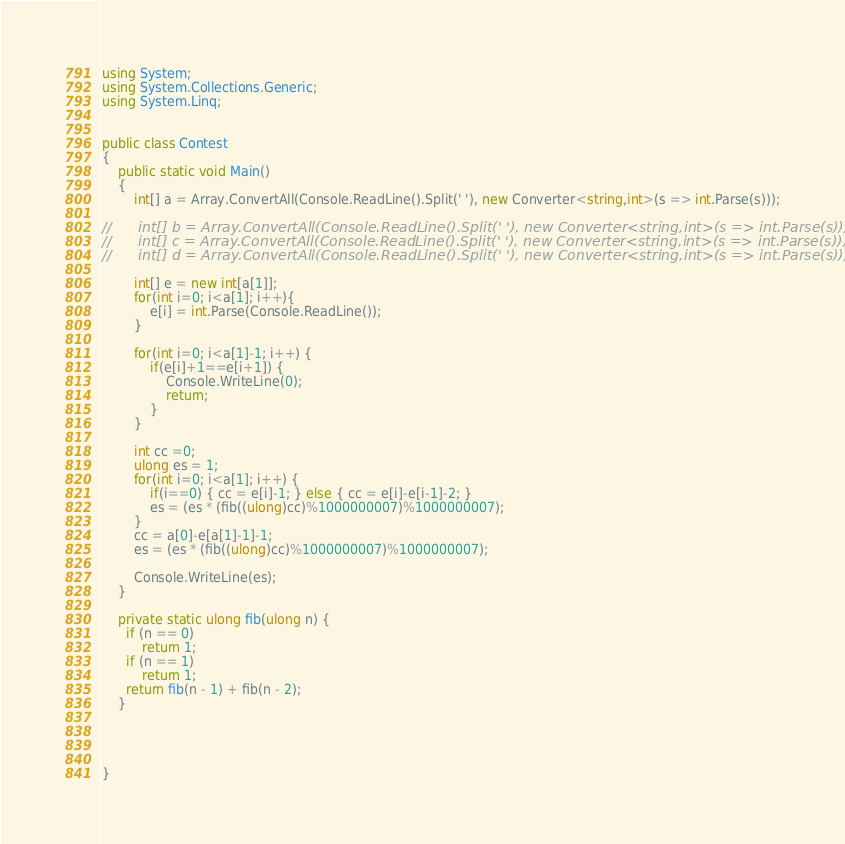<code> <loc_0><loc_0><loc_500><loc_500><_C#_>using System;
using System.Collections.Generic;
using System.Linq;


public class Contest
{
	public static void Main()
	{
		int[] a = Array.ConvertAll(Console.ReadLine().Split(' '), new Converter<string,int>(s => int.Parse(s)));

//		int[] b = Array.ConvertAll(Console.ReadLine().Split(' '), new Converter<string,int>(s => int.Parse(s)));
//		int[] c = Array.ConvertAll(Console.ReadLine().Split(' '), new Converter<string,int>(s => int.Parse(s)));
//		int[] d = Array.ConvertAll(Console.ReadLine().Split(' '), new Converter<string,int>(s => int.Parse(s)));
	
		int[] e = new int[a[1]];
		for(int i=0; i<a[1]; i++){
			e[i] = int.Parse(Console.ReadLine());
		}

		for(int i=0; i<a[1]-1; i++) {
			if(e[i]+1==e[i+1]) {
				Console.WriteLine(0);
				return;
			}
		}
		
		int cc =0;
		ulong es = 1;
		for(int i=0; i<a[1]; i++) {
			if(i==0) { cc = e[i]-1; } else { cc = e[i]-e[i-1]-2; }
			es = (es * (fib((ulong)cc)%1000000007)%1000000007); 
		}
		cc = a[0]-e[a[1]-1]-1;
		es = (es * (fib((ulong)cc)%1000000007)%1000000007); 

		Console.WriteLine(es);
	}
	
	private static ulong fib(ulong n) {
      if (n == 0)
          return 1;
      if (n == 1)
          return 1;
      return fib(n - 1) + fib(n - 2);
	}




}
</code> 